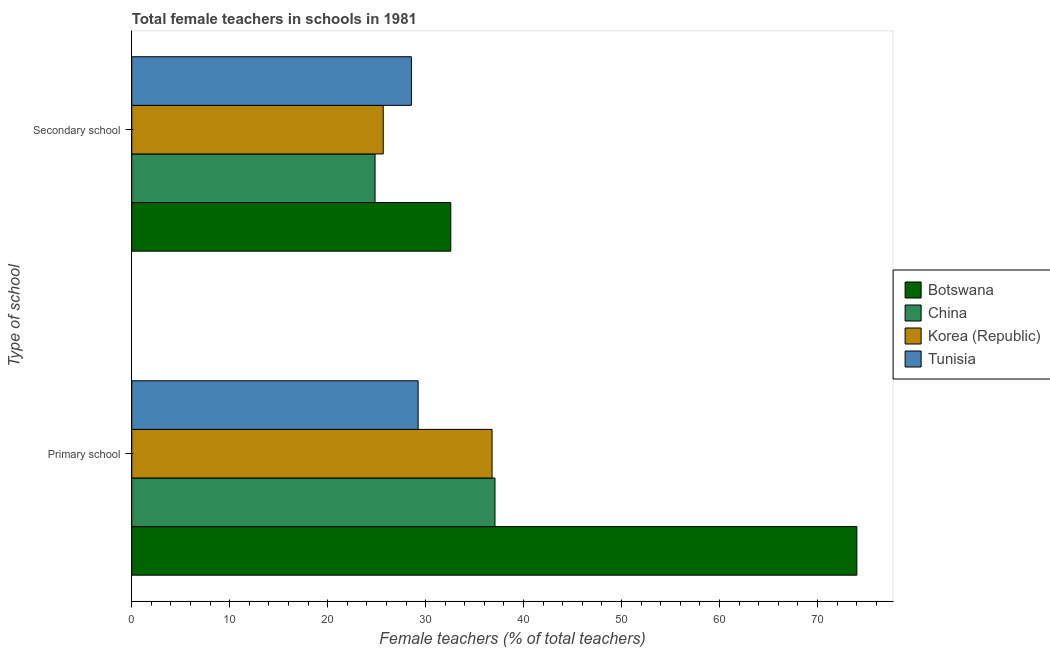How many different coloured bars are there?
Ensure brevity in your answer.  4. How many groups of bars are there?
Provide a succinct answer. 2. Are the number of bars per tick equal to the number of legend labels?
Offer a terse response. Yes. Are the number of bars on each tick of the Y-axis equal?
Provide a short and direct response. Yes. What is the label of the 1st group of bars from the top?
Your response must be concise. Secondary school. What is the percentage of female teachers in secondary schools in Botswana?
Offer a very short reply. 32.57. Across all countries, what is the maximum percentage of female teachers in secondary schools?
Your response must be concise. 32.57. Across all countries, what is the minimum percentage of female teachers in primary schools?
Provide a short and direct response. 29.23. In which country was the percentage of female teachers in secondary schools maximum?
Your answer should be compact. Botswana. In which country was the percentage of female teachers in secondary schools minimum?
Offer a very short reply. China. What is the total percentage of female teachers in secondary schools in the graph?
Your answer should be very brief. 111.63. What is the difference between the percentage of female teachers in secondary schools in China and that in Tunisia?
Your response must be concise. -3.72. What is the difference between the percentage of female teachers in secondary schools in Botswana and the percentage of female teachers in primary schools in Korea (Republic)?
Your answer should be compact. -4.21. What is the average percentage of female teachers in secondary schools per country?
Your answer should be compact. 27.91. What is the difference between the percentage of female teachers in secondary schools and percentage of female teachers in primary schools in China?
Keep it short and to the point. -12.24. What is the ratio of the percentage of female teachers in secondary schools in China to that in Tunisia?
Offer a very short reply. 0.87. Is the percentage of female teachers in secondary schools in Botswana less than that in China?
Your response must be concise. No. In how many countries, is the percentage of female teachers in secondary schools greater than the average percentage of female teachers in secondary schools taken over all countries?
Offer a terse response. 2. What does the 2nd bar from the top in Primary school represents?
Keep it short and to the point. Korea (Republic). What does the 2nd bar from the bottom in Secondary school represents?
Offer a terse response. China. How many countries are there in the graph?
Keep it short and to the point. 4. Are the values on the major ticks of X-axis written in scientific E-notation?
Your answer should be compact. No. Where does the legend appear in the graph?
Your response must be concise. Center right. How many legend labels are there?
Offer a very short reply. 4. What is the title of the graph?
Give a very brief answer. Total female teachers in schools in 1981. Does "Low income" appear as one of the legend labels in the graph?
Your answer should be very brief. No. What is the label or title of the X-axis?
Provide a short and direct response. Female teachers (% of total teachers). What is the label or title of the Y-axis?
Ensure brevity in your answer.  Type of school. What is the Female teachers (% of total teachers) of Botswana in Primary school?
Offer a terse response. 74.02. What is the Female teachers (% of total teachers) of China in Primary school?
Offer a very short reply. 37.08. What is the Female teachers (% of total teachers) in Korea (Republic) in Primary school?
Make the answer very short. 36.78. What is the Female teachers (% of total teachers) of Tunisia in Primary school?
Offer a terse response. 29.23. What is the Female teachers (% of total teachers) of Botswana in Secondary school?
Provide a short and direct response. 32.57. What is the Female teachers (% of total teachers) of China in Secondary school?
Your response must be concise. 24.84. What is the Female teachers (% of total teachers) in Korea (Republic) in Secondary school?
Make the answer very short. 25.68. What is the Female teachers (% of total teachers) of Tunisia in Secondary school?
Provide a succinct answer. 28.55. Across all Type of school, what is the maximum Female teachers (% of total teachers) of Botswana?
Provide a succinct answer. 74.02. Across all Type of school, what is the maximum Female teachers (% of total teachers) of China?
Your response must be concise. 37.08. Across all Type of school, what is the maximum Female teachers (% of total teachers) in Korea (Republic)?
Offer a very short reply. 36.78. Across all Type of school, what is the maximum Female teachers (% of total teachers) of Tunisia?
Keep it short and to the point. 29.23. Across all Type of school, what is the minimum Female teachers (% of total teachers) of Botswana?
Keep it short and to the point. 32.57. Across all Type of school, what is the minimum Female teachers (% of total teachers) of China?
Offer a terse response. 24.84. Across all Type of school, what is the minimum Female teachers (% of total teachers) in Korea (Republic)?
Provide a succinct answer. 25.68. Across all Type of school, what is the minimum Female teachers (% of total teachers) of Tunisia?
Offer a terse response. 28.55. What is the total Female teachers (% of total teachers) in Botswana in the graph?
Your answer should be very brief. 106.59. What is the total Female teachers (% of total teachers) in China in the graph?
Keep it short and to the point. 61.91. What is the total Female teachers (% of total teachers) of Korea (Republic) in the graph?
Ensure brevity in your answer.  62.46. What is the total Female teachers (% of total teachers) in Tunisia in the graph?
Your answer should be very brief. 57.79. What is the difference between the Female teachers (% of total teachers) of Botswana in Primary school and that in Secondary school?
Provide a succinct answer. 41.45. What is the difference between the Female teachers (% of total teachers) of China in Primary school and that in Secondary school?
Provide a short and direct response. 12.24. What is the difference between the Female teachers (% of total teachers) of Korea (Republic) in Primary school and that in Secondary school?
Give a very brief answer. 11.1. What is the difference between the Female teachers (% of total teachers) in Tunisia in Primary school and that in Secondary school?
Your response must be concise. 0.68. What is the difference between the Female teachers (% of total teachers) of Botswana in Primary school and the Female teachers (% of total teachers) of China in Secondary school?
Provide a succinct answer. 49.19. What is the difference between the Female teachers (% of total teachers) of Botswana in Primary school and the Female teachers (% of total teachers) of Korea (Republic) in Secondary school?
Your answer should be compact. 48.35. What is the difference between the Female teachers (% of total teachers) of Botswana in Primary school and the Female teachers (% of total teachers) of Tunisia in Secondary school?
Your response must be concise. 45.47. What is the difference between the Female teachers (% of total teachers) in China in Primary school and the Female teachers (% of total teachers) in Korea (Republic) in Secondary school?
Make the answer very short. 11.4. What is the difference between the Female teachers (% of total teachers) in China in Primary school and the Female teachers (% of total teachers) in Tunisia in Secondary school?
Offer a terse response. 8.53. What is the difference between the Female teachers (% of total teachers) of Korea (Republic) in Primary school and the Female teachers (% of total teachers) of Tunisia in Secondary school?
Ensure brevity in your answer.  8.23. What is the average Female teachers (% of total teachers) in Botswana per Type of school?
Provide a succinct answer. 53.3. What is the average Female teachers (% of total teachers) in China per Type of school?
Provide a short and direct response. 30.96. What is the average Female teachers (% of total teachers) in Korea (Republic) per Type of school?
Provide a succinct answer. 31.23. What is the average Female teachers (% of total teachers) in Tunisia per Type of school?
Ensure brevity in your answer.  28.89. What is the difference between the Female teachers (% of total teachers) in Botswana and Female teachers (% of total teachers) in China in Primary school?
Your answer should be very brief. 36.94. What is the difference between the Female teachers (% of total teachers) of Botswana and Female teachers (% of total teachers) of Korea (Republic) in Primary school?
Offer a very short reply. 37.24. What is the difference between the Female teachers (% of total teachers) of Botswana and Female teachers (% of total teachers) of Tunisia in Primary school?
Offer a terse response. 44.79. What is the difference between the Female teachers (% of total teachers) in China and Female teachers (% of total teachers) in Korea (Republic) in Primary school?
Your response must be concise. 0.3. What is the difference between the Female teachers (% of total teachers) of China and Female teachers (% of total teachers) of Tunisia in Primary school?
Your response must be concise. 7.84. What is the difference between the Female teachers (% of total teachers) of Korea (Republic) and Female teachers (% of total teachers) of Tunisia in Primary school?
Your answer should be very brief. 7.55. What is the difference between the Female teachers (% of total teachers) of Botswana and Female teachers (% of total teachers) of China in Secondary school?
Provide a succinct answer. 7.73. What is the difference between the Female teachers (% of total teachers) of Botswana and Female teachers (% of total teachers) of Korea (Republic) in Secondary school?
Offer a very short reply. 6.89. What is the difference between the Female teachers (% of total teachers) of Botswana and Female teachers (% of total teachers) of Tunisia in Secondary school?
Make the answer very short. 4.02. What is the difference between the Female teachers (% of total teachers) of China and Female teachers (% of total teachers) of Korea (Republic) in Secondary school?
Make the answer very short. -0.84. What is the difference between the Female teachers (% of total teachers) of China and Female teachers (% of total teachers) of Tunisia in Secondary school?
Your response must be concise. -3.72. What is the difference between the Female teachers (% of total teachers) in Korea (Republic) and Female teachers (% of total teachers) in Tunisia in Secondary school?
Provide a succinct answer. -2.88. What is the ratio of the Female teachers (% of total teachers) in Botswana in Primary school to that in Secondary school?
Offer a very short reply. 2.27. What is the ratio of the Female teachers (% of total teachers) in China in Primary school to that in Secondary school?
Provide a short and direct response. 1.49. What is the ratio of the Female teachers (% of total teachers) in Korea (Republic) in Primary school to that in Secondary school?
Your answer should be compact. 1.43. What is the ratio of the Female teachers (% of total teachers) of Tunisia in Primary school to that in Secondary school?
Keep it short and to the point. 1.02. What is the difference between the highest and the second highest Female teachers (% of total teachers) of Botswana?
Your answer should be compact. 41.45. What is the difference between the highest and the second highest Female teachers (% of total teachers) of China?
Keep it short and to the point. 12.24. What is the difference between the highest and the second highest Female teachers (% of total teachers) in Korea (Republic)?
Provide a short and direct response. 11.1. What is the difference between the highest and the second highest Female teachers (% of total teachers) of Tunisia?
Make the answer very short. 0.68. What is the difference between the highest and the lowest Female teachers (% of total teachers) in Botswana?
Offer a very short reply. 41.45. What is the difference between the highest and the lowest Female teachers (% of total teachers) in China?
Your answer should be very brief. 12.24. What is the difference between the highest and the lowest Female teachers (% of total teachers) of Korea (Republic)?
Your answer should be very brief. 11.1. What is the difference between the highest and the lowest Female teachers (% of total teachers) of Tunisia?
Ensure brevity in your answer.  0.68. 